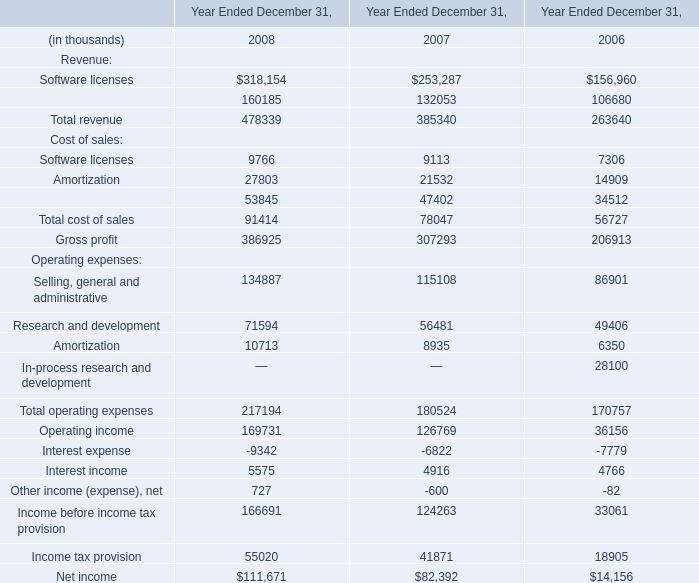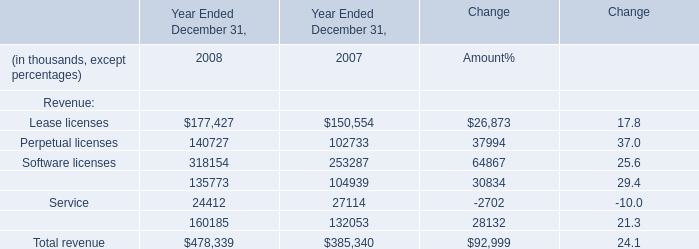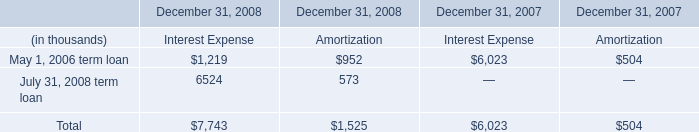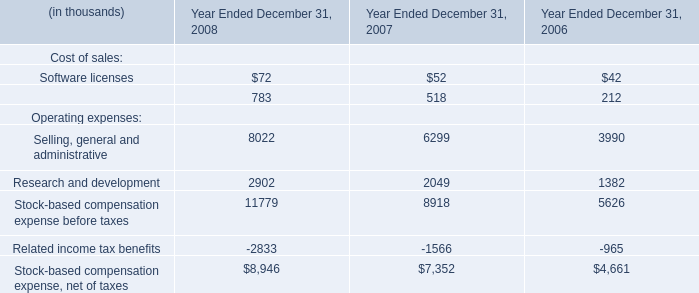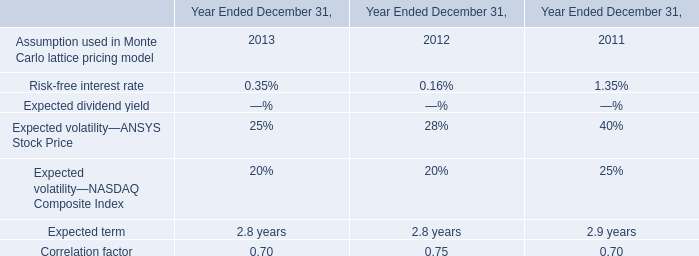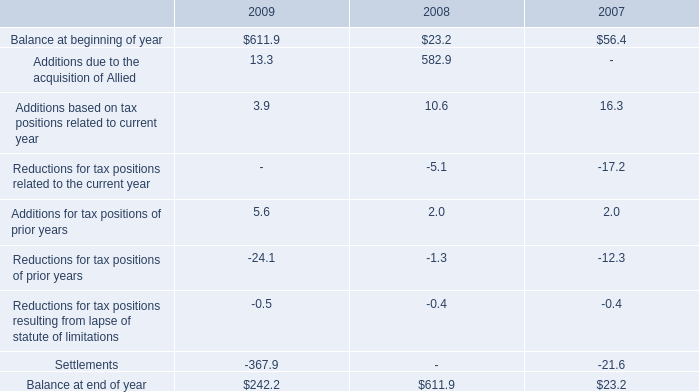as of december 31 , 2009 , what was the percent unrecognized tax benefits related to tax positions taken by allied prior to the merger . 
Computations: (211.9 / 242.2)
Answer: 0.8749. 